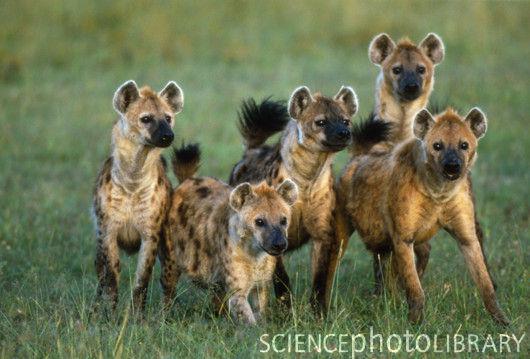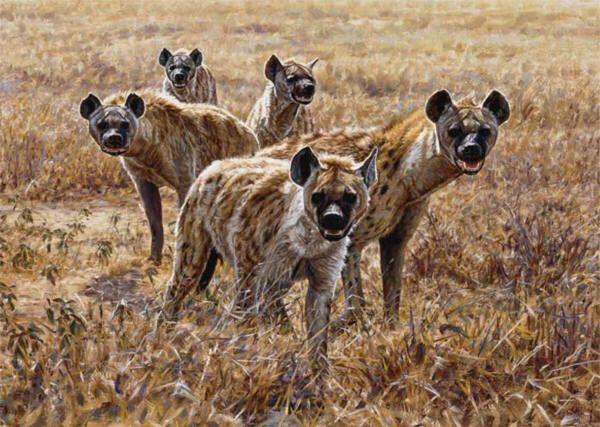The first image is the image on the left, the second image is the image on the right. Given the left and right images, does the statement "One hyena sits while two stand on either side of it." hold true? Answer yes or no. No. 